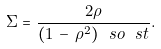<formula> <loc_0><loc_0><loc_500><loc_500>\Sigma = \frac { 2 \rho } { ( 1 \, - \, \rho ^ { 2 } ) \ s o \ s t } .</formula> 